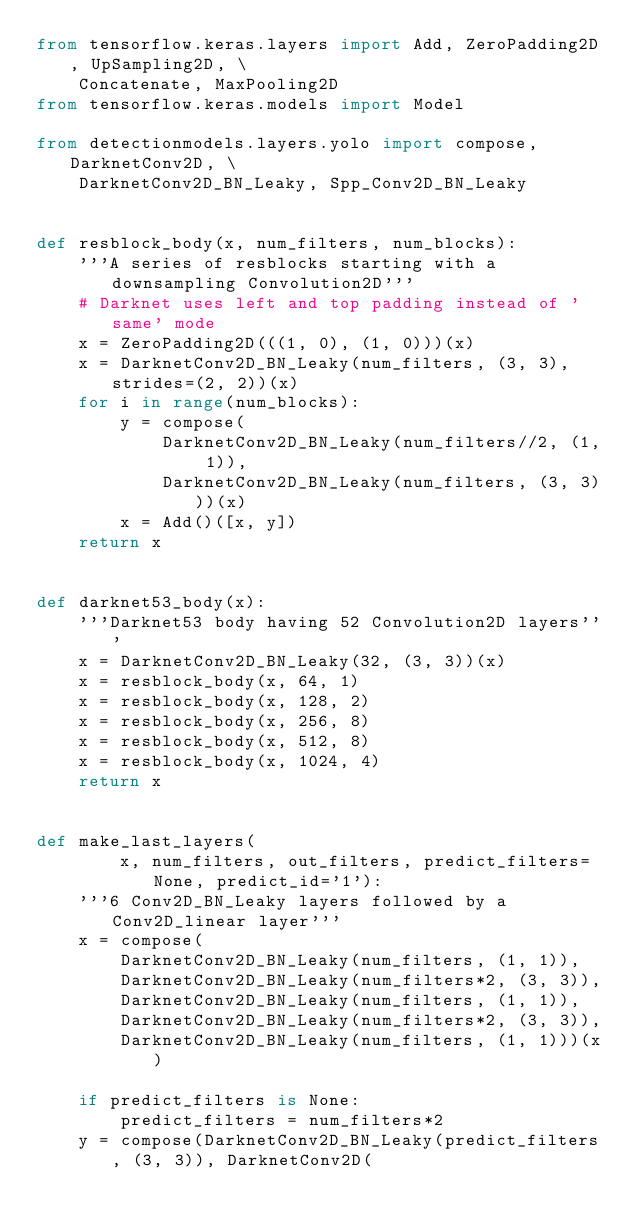<code> <loc_0><loc_0><loc_500><loc_500><_Python_>from tensorflow.keras.layers import Add, ZeroPadding2D, UpSampling2D, \
    Concatenate, MaxPooling2D
from tensorflow.keras.models import Model

from detectionmodels.layers.yolo import compose, DarknetConv2D, \
    DarknetConv2D_BN_Leaky, Spp_Conv2D_BN_Leaky


def resblock_body(x, num_filters, num_blocks):
    '''A series of resblocks starting with a downsampling Convolution2D'''
    # Darknet uses left and top padding instead of 'same' mode
    x = ZeroPadding2D(((1, 0), (1, 0)))(x)
    x = DarknetConv2D_BN_Leaky(num_filters, (3, 3), strides=(2, 2))(x)
    for i in range(num_blocks):
        y = compose(
            DarknetConv2D_BN_Leaky(num_filters//2, (1, 1)),
            DarknetConv2D_BN_Leaky(num_filters, (3, 3)))(x)
        x = Add()([x, y])
    return x


def darknet53_body(x):
    '''Darknet53 body having 52 Convolution2D layers'''
    x = DarknetConv2D_BN_Leaky(32, (3, 3))(x)
    x = resblock_body(x, 64, 1)
    x = resblock_body(x, 128, 2)
    x = resblock_body(x, 256, 8)
    x = resblock_body(x, 512, 8)
    x = resblock_body(x, 1024, 4)
    return x


def make_last_layers(
        x, num_filters, out_filters, predict_filters=None, predict_id='1'):
    '''6 Conv2D_BN_Leaky layers followed by a Conv2D_linear layer'''
    x = compose(
        DarknetConv2D_BN_Leaky(num_filters, (1, 1)),
        DarknetConv2D_BN_Leaky(num_filters*2, (3, 3)),
        DarknetConv2D_BN_Leaky(num_filters, (1, 1)),
        DarknetConv2D_BN_Leaky(num_filters*2, (3, 3)),
        DarknetConv2D_BN_Leaky(num_filters, (1, 1)))(x)

    if predict_filters is None:
        predict_filters = num_filters*2
    y = compose(DarknetConv2D_BN_Leaky(predict_filters, (3, 3)), DarknetConv2D(</code> 